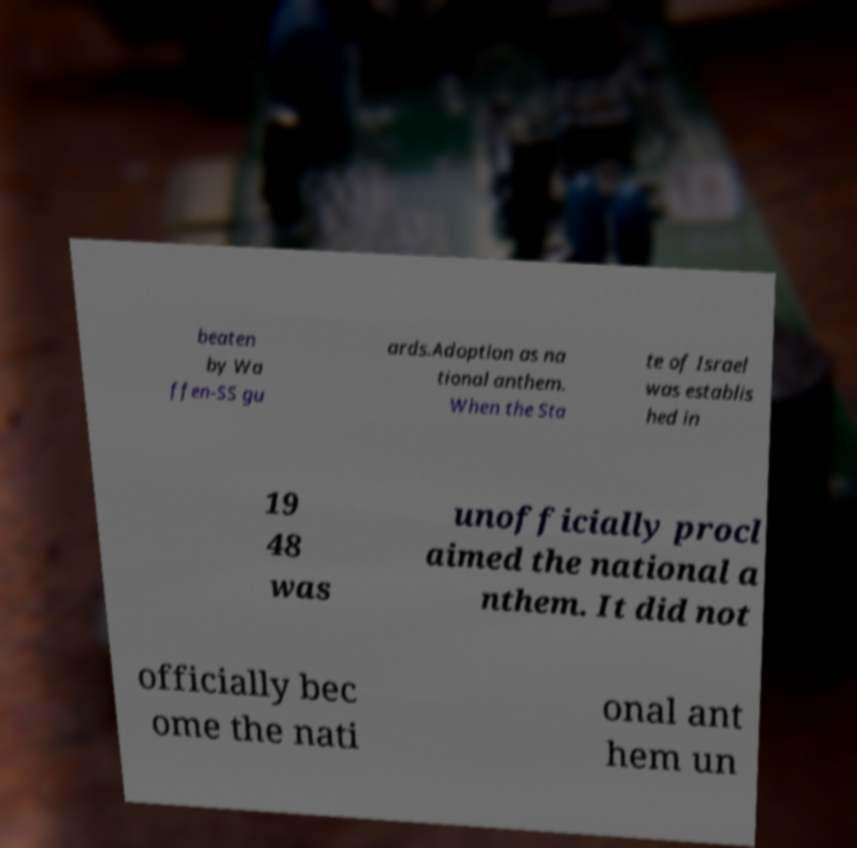I need the written content from this picture converted into text. Can you do that? beaten by Wa ffen-SS gu ards.Adoption as na tional anthem. When the Sta te of Israel was establis hed in 19 48 was unofficially procl aimed the national a nthem. It did not officially bec ome the nati onal ant hem un 